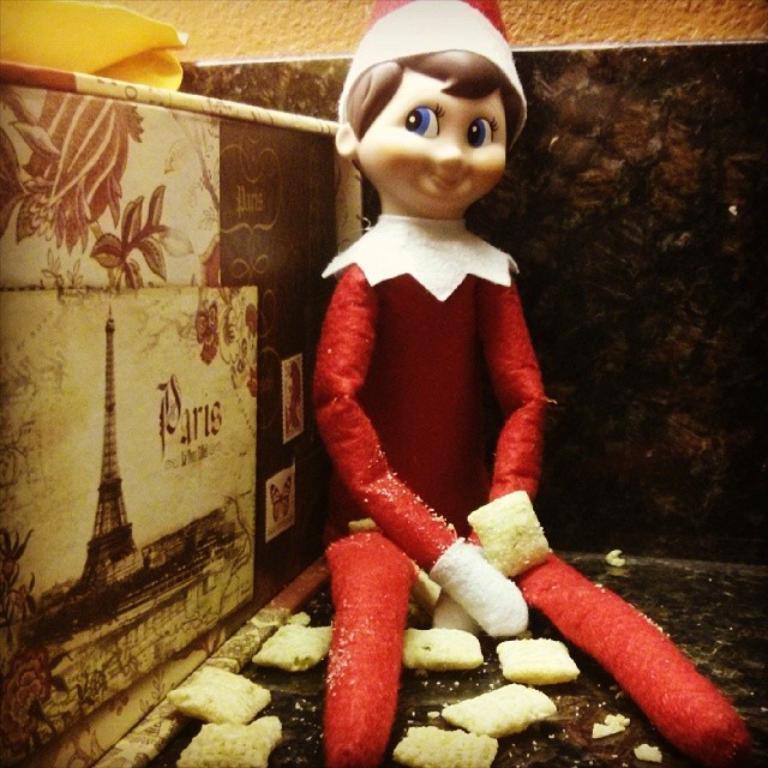Please provide a concise description of this image. In this picture we can see a toy smiling and some objects on the floor and beside this toy we can see the wall with a painting on it and in the background we can see the wall. 